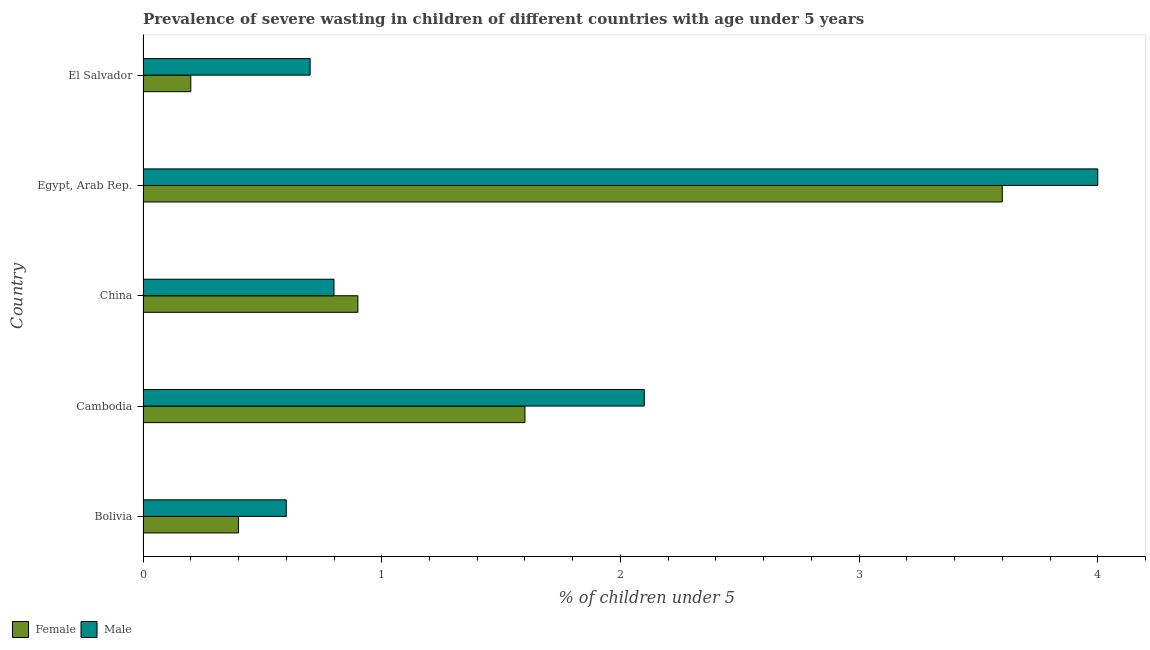How many bars are there on the 1st tick from the bottom?
Make the answer very short. 2. What is the label of the 4th group of bars from the top?
Provide a short and direct response. Cambodia. What is the percentage of undernourished male children in China?
Offer a very short reply. 0.8. Across all countries, what is the maximum percentage of undernourished female children?
Give a very brief answer. 3.6. Across all countries, what is the minimum percentage of undernourished male children?
Ensure brevity in your answer.  0.6. In which country was the percentage of undernourished female children maximum?
Your answer should be compact. Egypt, Arab Rep. In which country was the percentage of undernourished male children minimum?
Make the answer very short. Bolivia. What is the total percentage of undernourished female children in the graph?
Provide a short and direct response. 6.7. What is the difference between the percentage of undernourished male children in Bolivia and the percentage of undernourished female children in Cambodia?
Provide a short and direct response. -1. What is the average percentage of undernourished male children per country?
Provide a succinct answer. 1.64. What is the difference between the highest and the second highest percentage of undernourished female children?
Keep it short and to the point. 2. What is the difference between the highest and the lowest percentage of undernourished female children?
Offer a terse response. 3.4. What does the 2nd bar from the top in El Salvador represents?
Give a very brief answer. Female. How many bars are there?
Ensure brevity in your answer.  10. Are all the bars in the graph horizontal?
Your answer should be compact. Yes. Are the values on the major ticks of X-axis written in scientific E-notation?
Offer a very short reply. No. Does the graph contain any zero values?
Keep it short and to the point. No. Does the graph contain grids?
Your response must be concise. No. Where does the legend appear in the graph?
Your response must be concise. Bottom left. How many legend labels are there?
Make the answer very short. 2. How are the legend labels stacked?
Keep it short and to the point. Horizontal. What is the title of the graph?
Offer a very short reply. Prevalence of severe wasting in children of different countries with age under 5 years. What is the label or title of the X-axis?
Keep it short and to the point.  % of children under 5. What is the label or title of the Y-axis?
Ensure brevity in your answer.  Country. What is the  % of children under 5 in Female in Bolivia?
Your answer should be very brief. 0.4. What is the  % of children under 5 of Male in Bolivia?
Your response must be concise. 0.6. What is the  % of children under 5 in Female in Cambodia?
Keep it short and to the point. 1.6. What is the  % of children under 5 in Male in Cambodia?
Give a very brief answer. 2.1. What is the  % of children under 5 in Female in China?
Your answer should be very brief. 0.9. What is the  % of children under 5 in Male in China?
Your response must be concise. 0.8. What is the  % of children under 5 of Female in Egypt, Arab Rep.?
Your answer should be very brief. 3.6. What is the  % of children under 5 in Female in El Salvador?
Offer a terse response. 0.2. What is the  % of children under 5 in Male in El Salvador?
Your answer should be very brief. 0.7. Across all countries, what is the maximum  % of children under 5 of Female?
Your answer should be very brief. 3.6. Across all countries, what is the minimum  % of children under 5 in Female?
Provide a short and direct response. 0.2. Across all countries, what is the minimum  % of children under 5 of Male?
Offer a very short reply. 0.6. What is the total  % of children under 5 in Female in the graph?
Give a very brief answer. 6.7. What is the total  % of children under 5 in Male in the graph?
Offer a terse response. 8.2. What is the difference between the  % of children under 5 in Male in Bolivia and that in China?
Provide a succinct answer. -0.2. What is the difference between the  % of children under 5 of Female in Bolivia and that in Egypt, Arab Rep.?
Make the answer very short. -3.2. What is the difference between the  % of children under 5 in Male in Bolivia and that in Egypt, Arab Rep.?
Your answer should be compact. -3.4. What is the difference between the  % of children under 5 in Female in Bolivia and that in El Salvador?
Give a very brief answer. 0.2. What is the difference between the  % of children under 5 in Male in Bolivia and that in El Salvador?
Your answer should be very brief. -0.1. What is the difference between the  % of children under 5 in Male in Cambodia and that in El Salvador?
Offer a terse response. 1.4. What is the difference between the  % of children under 5 in Male in Egypt, Arab Rep. and that in El Salvador?
Offer a terse response. 3.3. What is the difference between the  % of children under 5 in Female in Bolivia and the  % of children under 5 in Male in Egypt, Arab Rep.?
Your response must be concise. -3.6. What is the difference between the  % of children under 5 in Female in Cambodia and the  % of children under 5 in Male in Egypt, Arab Rep.?
Make the answer very short. -2.4. What is the difference between the  % of children under 5 of Female in Egypt, Arab Rep. and the  % of children under 5 of Male in El Salvador?
Make the answer very short. 2.9. What is the average  % of children under 5 of Female per country?
Give a very brief answer. 1.34. What is the average  % of children under 5 in Male per country?
Offer a terse response. 1.64. What is the difference between the  % of children under 5 in Female and  % of children under 5 in Male in Cambodia?
Provide a short and direct response. -0.5. What is the difference between the  % of children under 5 of Female and  % of children under 5 of Male in China?
Your response must be concise. 0.1. What is the ratio of the  % of children under 5 in Male in Bolivia to that in Cambodia?
Offer a terse response. 0.29. What is the ratio of the  % of children under 5 of Female in Bolivia to that in China?
Your response must be concise. 0.44. What is the ratio of the  % of children under 5 in Male in Bolivia to that in China?
Your response must be concise. 0.75. What is the ratio of the  % of children under 5 in Female in Cambodia to that in China?
Provide a short and direct response. 1.78. What is the ratio of the  % of children under 5 in Male in Cambodia to that in China?
Give a very brief answer. 2.62. What is the ratio of the  % of children under 5 of Female in Cambodia to that in Egypt, Arab Rep.?
Ensure brevity in your answer.  0.44. What is the ratio of the  % of children under 5 in Male in Cambodia to that in Egypt, Arab Rep.?
Provide a short and direct response. 0.53. What is the ratio of the  % of children under 5 in Female in Cambodia to that in El Salvador?
Ensure brevity in your answer.  8. What is the ratio of the  % of children under 5 in Male in Cambodia to that in El Salvador?
Offer a terse response. 3. What is the ratio of the  % of children under 5 of Male in China to that in Egypt, Arab Rep.?
Provide a short and direct response. 0.2. What is the ratio of the  % of children under 5 of Male in Egypt, Arab Rep. to that in El Salvador?
Offer a terse response. 5.71. What is the difference between the highest and the second highest  % of children under 5 in Male?
Keep it short and to the point. 1.9. What is the difference between the highest and the lowest  % of children under 5 in Female?
Offer a terse response. 3.4. What is the difference between the highest and the lowest  % of children under 5 of Male?
Offer a very short reply. 3.4. 